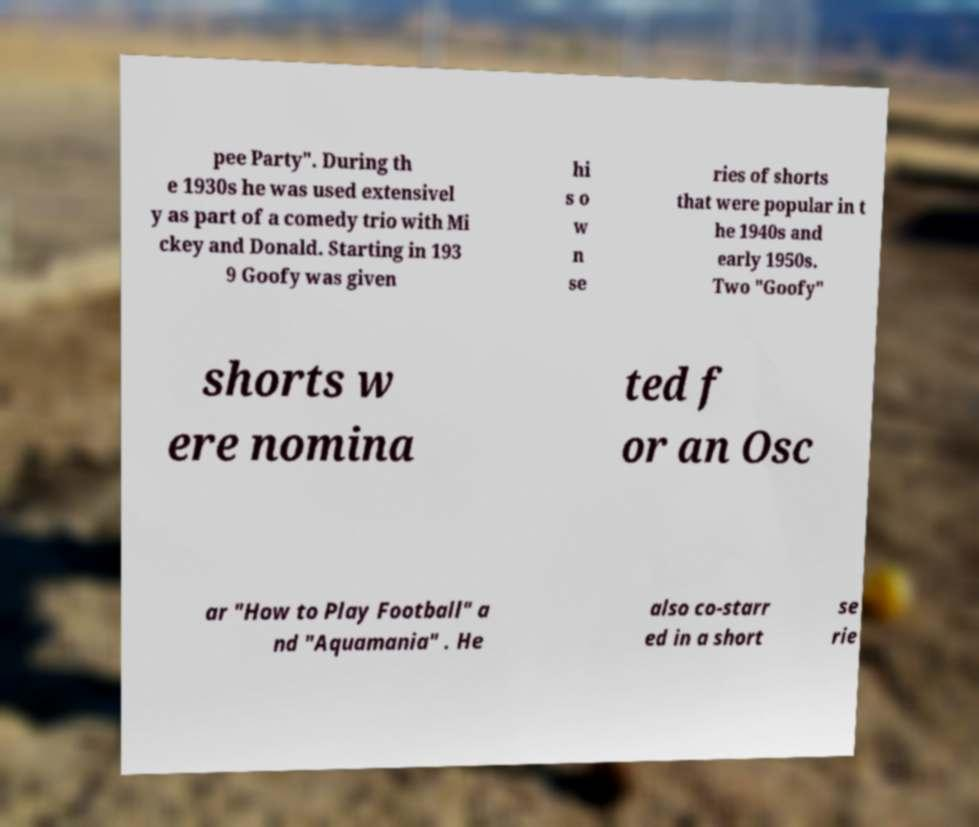Can you accurately transcribe the text from the provided image for me? pee Party". During th e 1930s he was used extensivel y as part of a comedy trio with Mi ckey and Donald. Starting in 193 9 Goofy was given hi s o w n se ries of shorts that were popular in t he 1940s and early 1950s. Two "Goofy" shorts w ere nomina ted f or an Osc ar "How to Play Football" a nd "Aquamania" . He also co-starr ed in a short se rie 